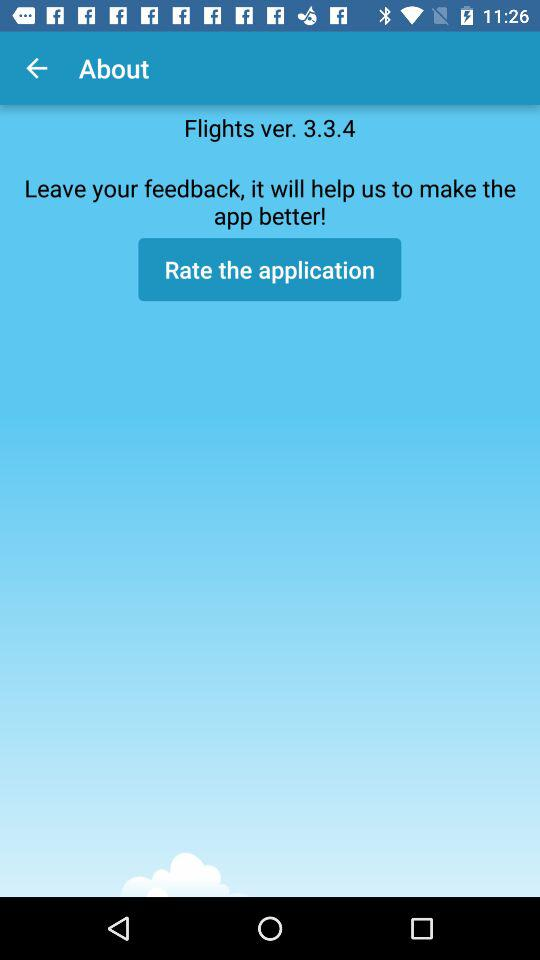Which version is this? It is version 3.3.4. 